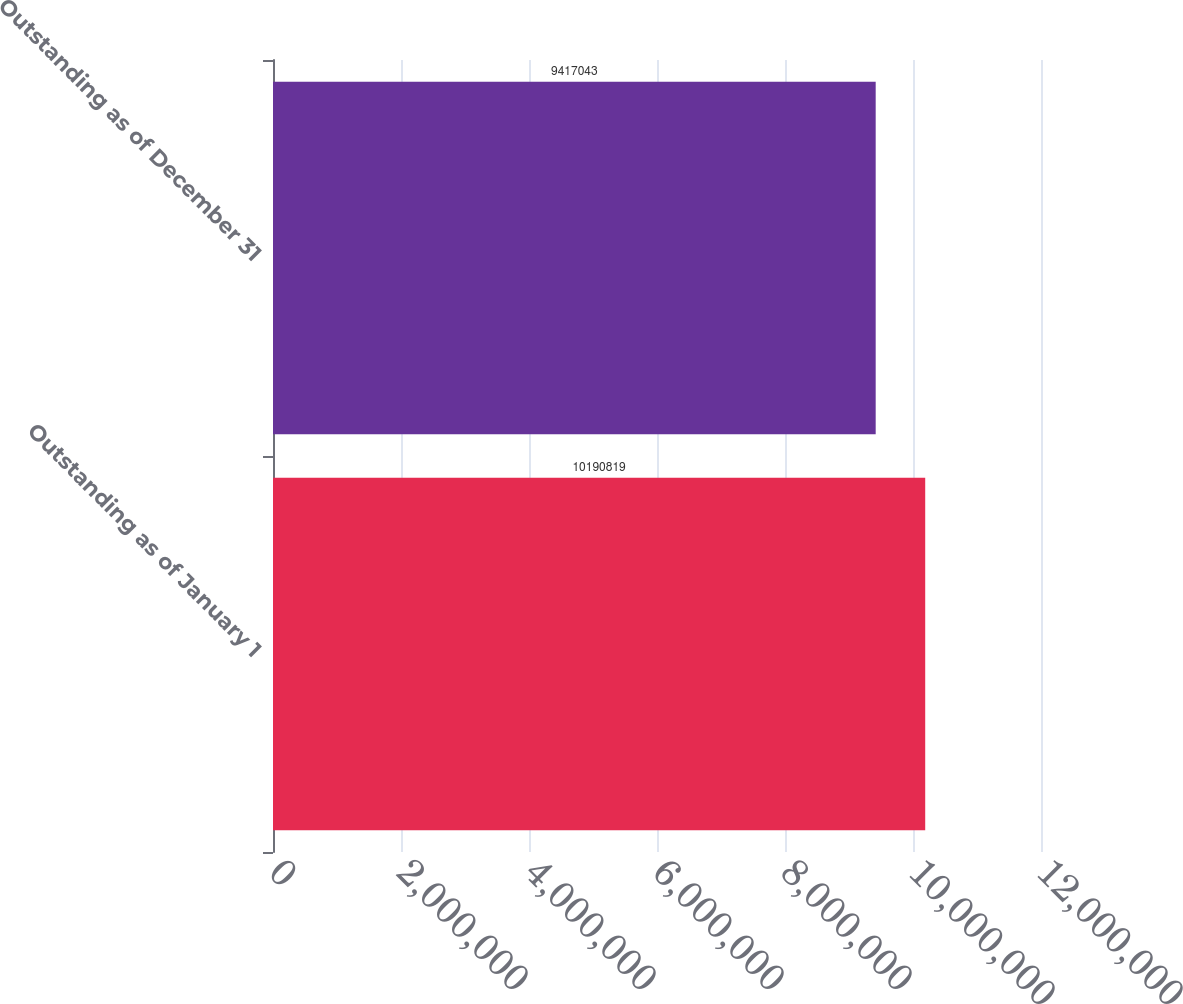Convert chart to OTSL. <chart><loc_0><loc_0><loc_500><loc_500><bar_chart><fcel>Outstanding as of January 1<fcel>Outstanding as of December 31<nl><fcel>1.01908e+07<fcel>9.41704e+06<nl></chart> 